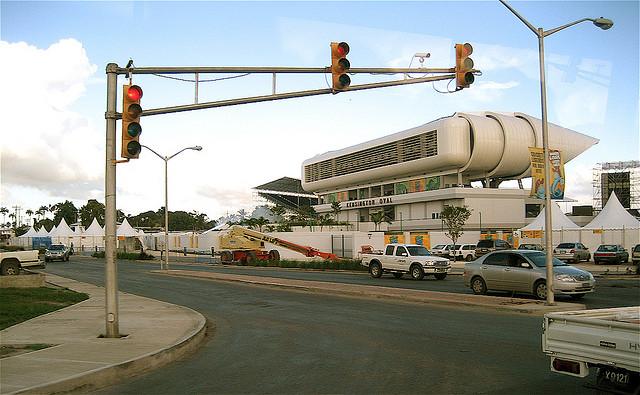What color is the truck?
Be succinct. White. What color are the traffic lights?
Write a very short answer. Red. How many trucks are there?
Keep it brief. 3. How many trucks are at the intersection?
Concise answer only. 1. What are they working on?
Write a very short answer. Building. Where is this?
Answer briefly. City. How many trucks can be seen?
Give a very brief answer. 1. 